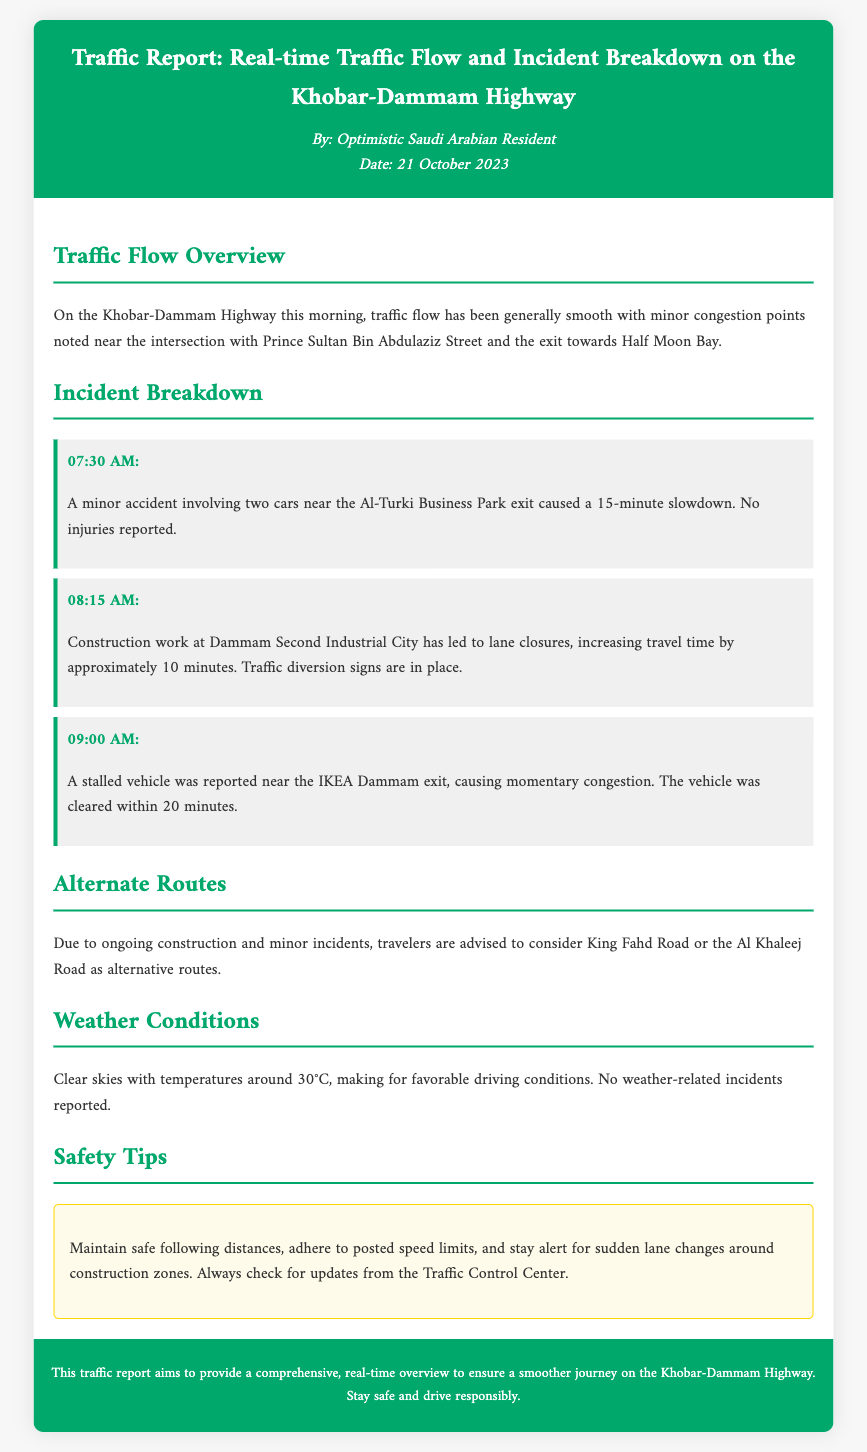What is the date of the report? The date of the report is explicitly mentioned in the document.
Answer: 21 October 2023 What caused the 15-minute slowdown at 07:30 AM? The slowdown was caused by a minor accident involving two cars near the Al-Turki Business Park exit.
Answer: A minor accident What is the estimated delay caused by construction at Dammam Second Industrial City? The document specifies the increased travel time due to construction work.
Answer: Approximately 10 minutes Which route is recommended as an alternative to Khobar-Dammam Highway? The document identifies alternative routes for travelers.
Answer: King Fahd Road What time was the stalled vehicle reported? The exact time of the reported stalled vehicle is given in the incident section.
Answer: 09:00 AM What were the weather conditions reported for the highway? The document provides a brief overview of the weather conditions affecting travel.
Answer: Clear skies How many incidents are reported in the breakdown section? The report lists three specific incidents that occurred on the highway.
Answer: Three incidents What is suggested for maintaining safety in construction zones? The safety tip includes specific measures to ensure safe driving.
Answer: Maintain safe following distances What was the temperature reported at the time of the traffic report? The weather section mentions the temperature during the morning.
Answer: 30°C 